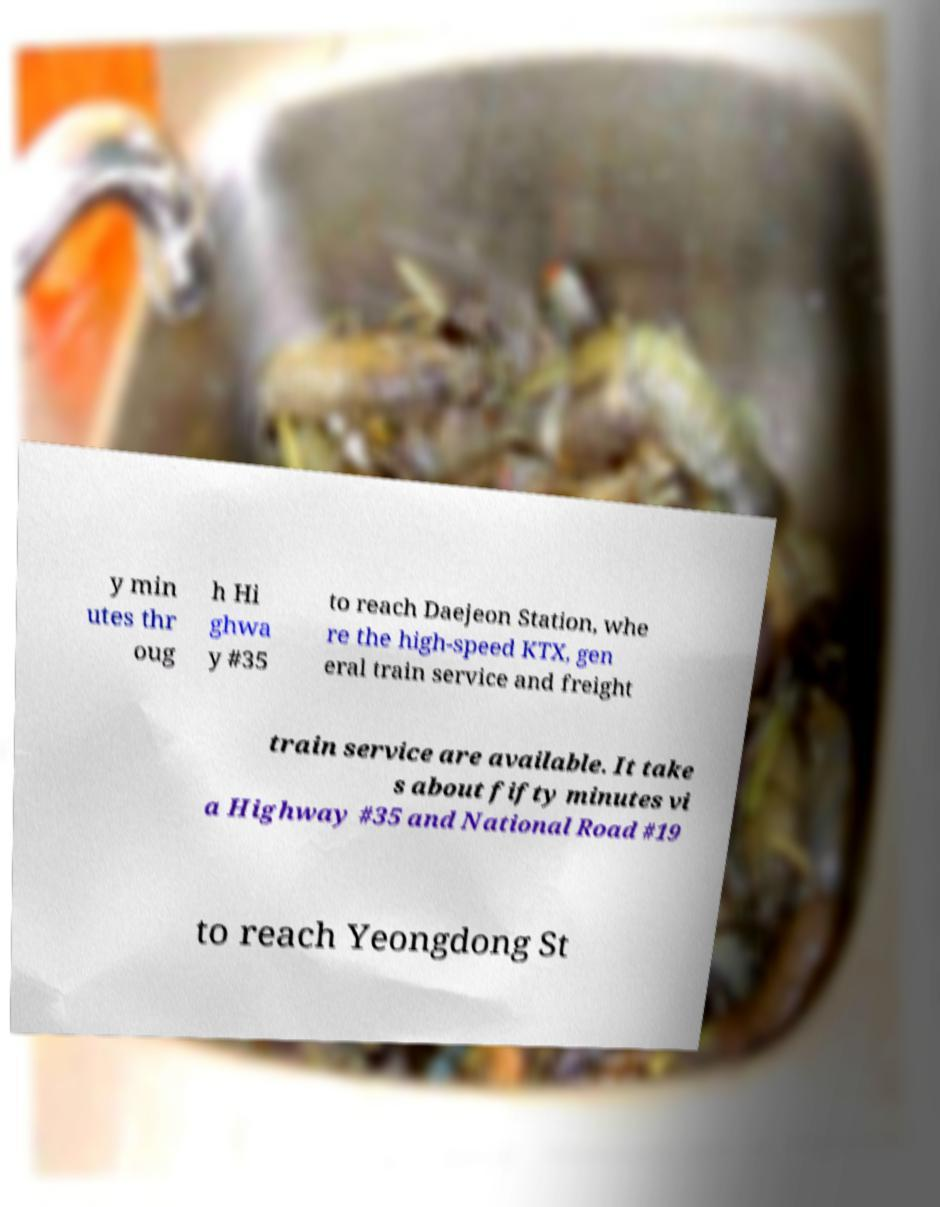Could you assist in decoding the text presented in this image and type it out clearly? y min utes thr oug h Hi ghwa y #35 to reach Daejeon Station, whe re the high-speed KTX, gen eral train service and freight train service are available. It take s about fifty minutes vi a Highway #35 and National Road #19 to reach Yeongdong St 